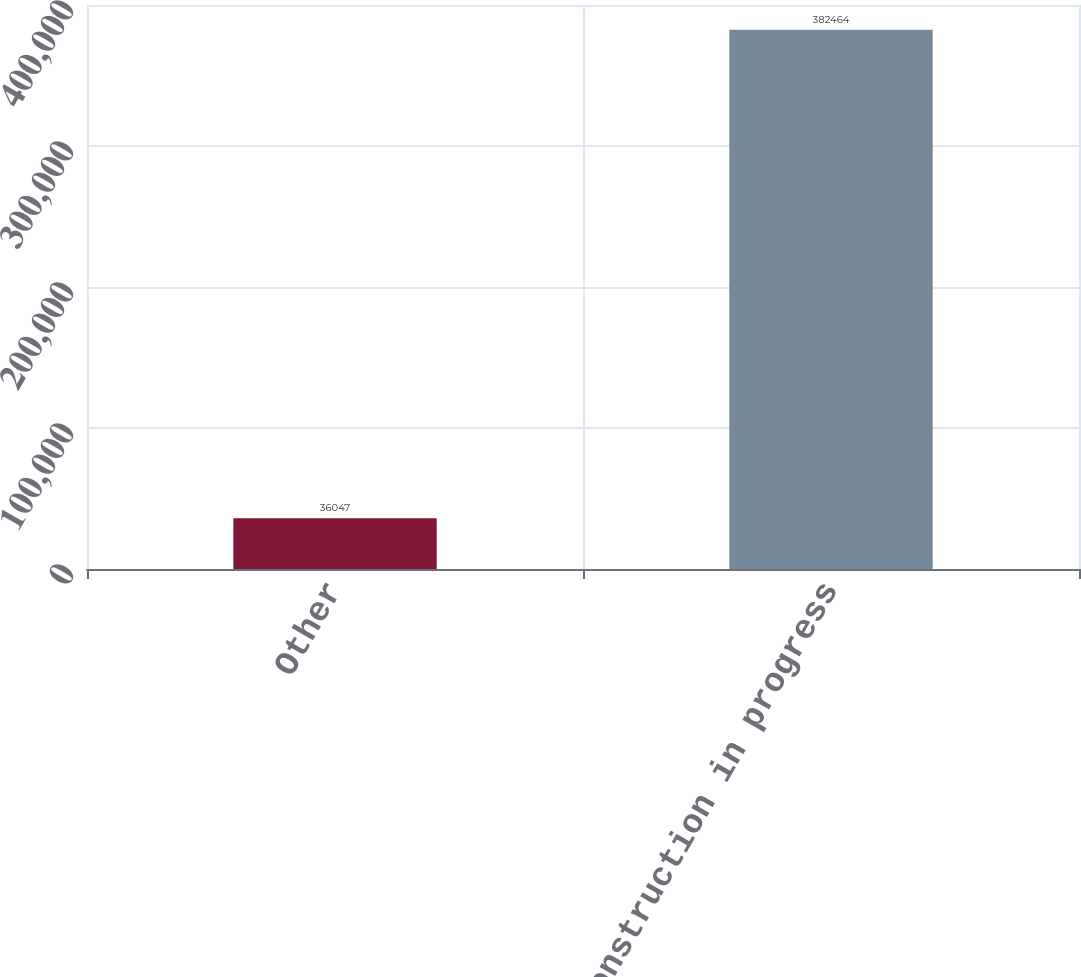Convert chart. <chart><loc_0><loc_0><loc_500><loc_500><bar_chart><fcel>Other<fcel>Total construction in progress<nl><fcel>36047<fcel>382464<nl></chart> 